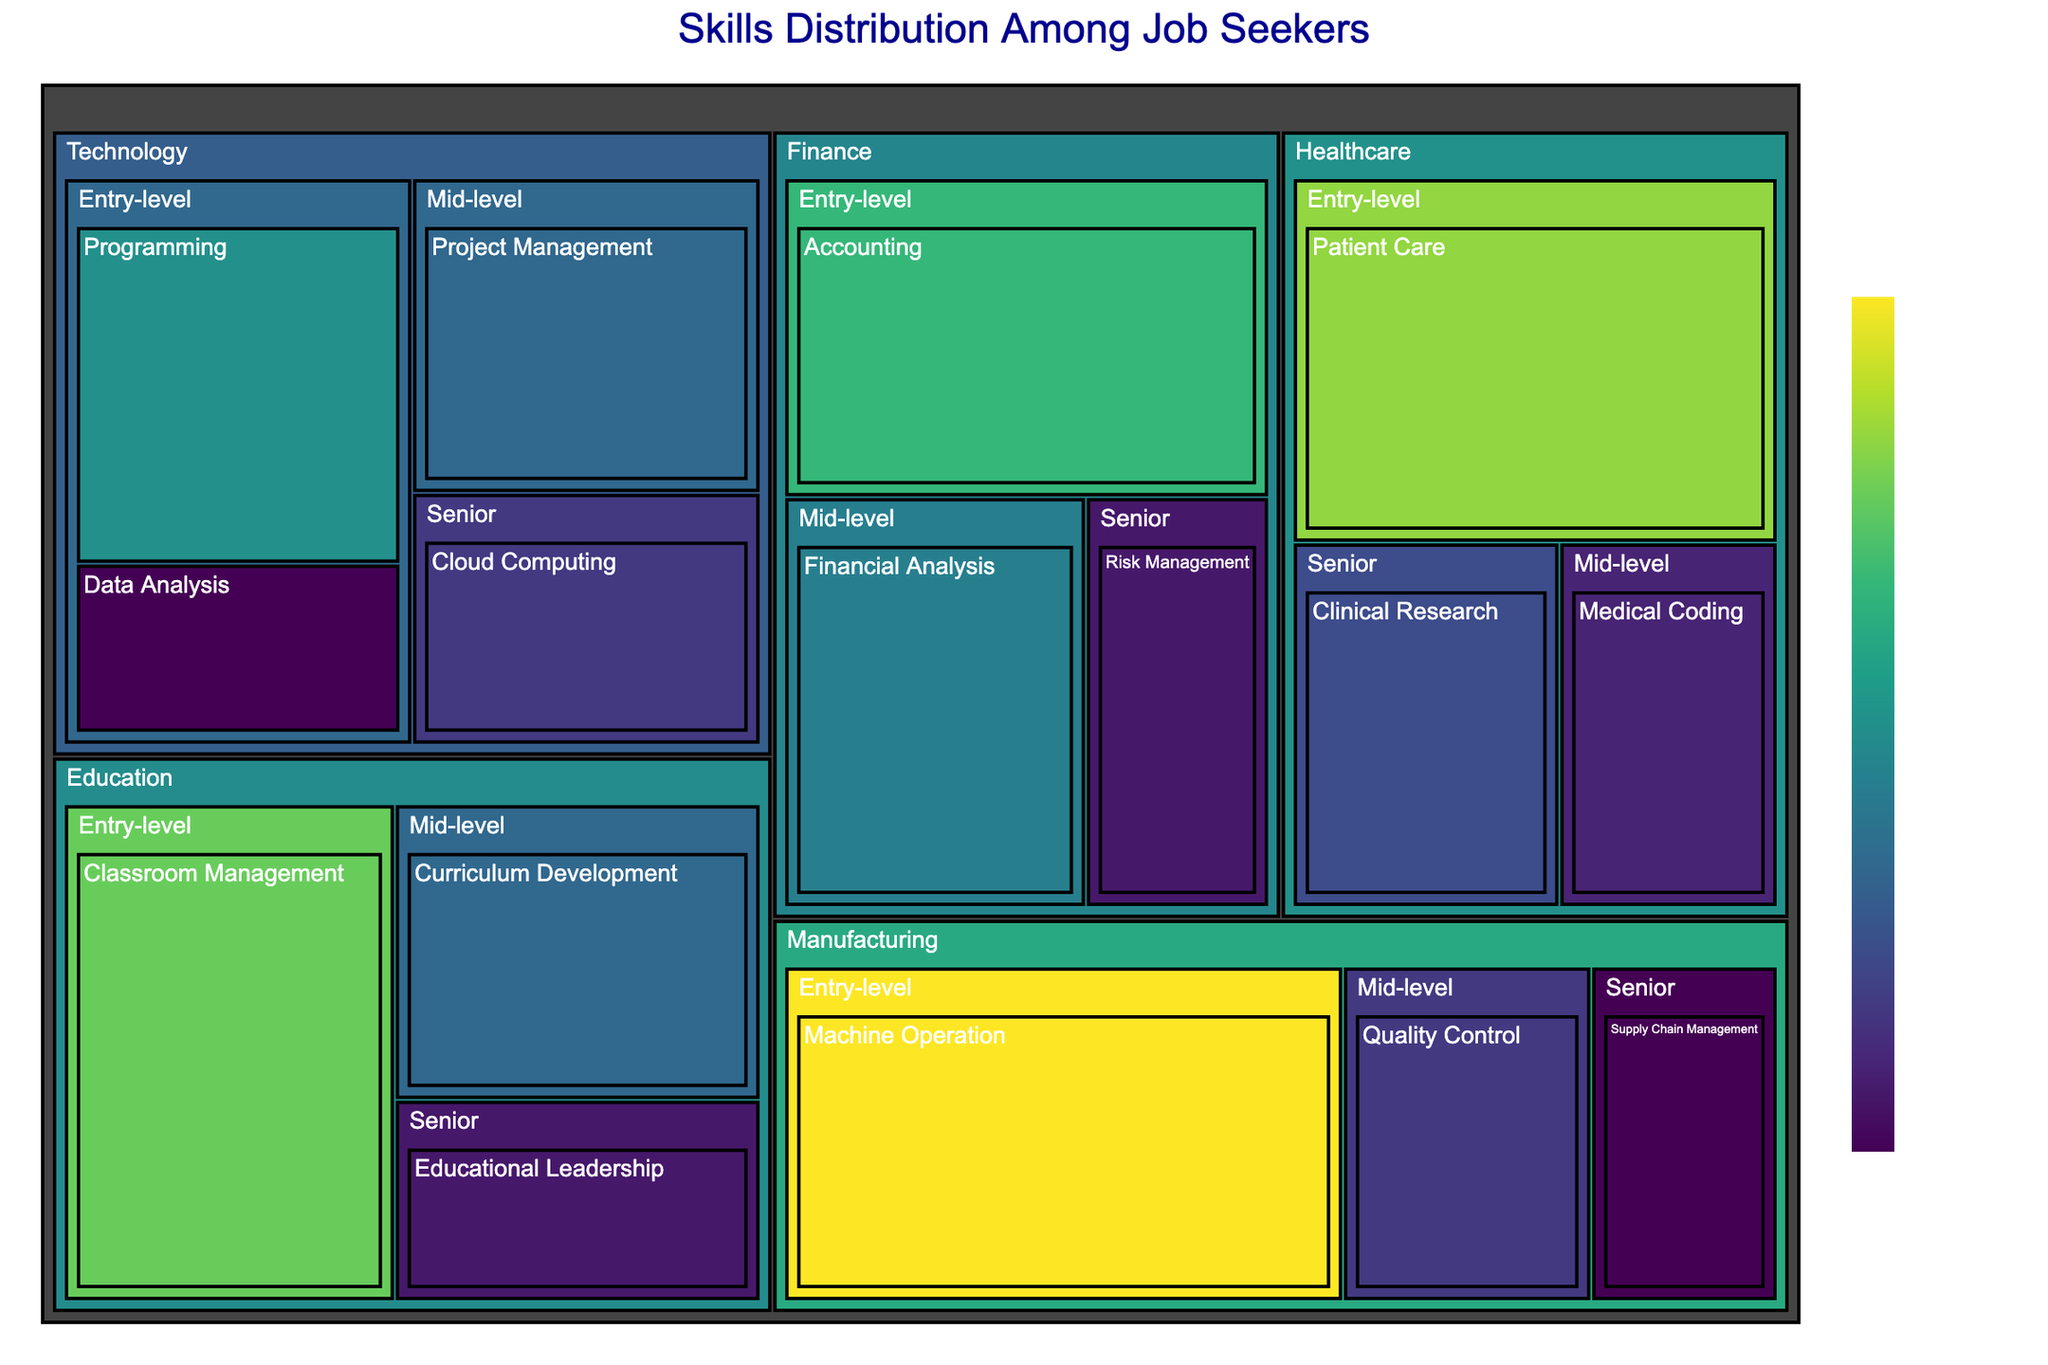What is the title of the treemap? The title of the treemap is usually displayed at the top and offers a summary of what the chart is about. Here, it is shown clearly in a large font.
Answer: Skills Distribution Among Job Seekers Which industry has the highest value for an entry-level skill, and what is that skill? Identify the entry-level category for each industry and look at the value of the skills listed. The highest value is where the rectangle size is the largest.
Answer: Manufacturing with Machine Operation Compare the skill demand in the Technology industry for entry-level and mid-level job seekers. Which level has a higher total demand? Sum the values of the skills for entry-level (30 + 15) and mid-level (25) job seekers in Technology. Entry-level: 45, Mid-level: 25. Entry-level has a higher total demand.
Answer: Entry-level What skill in Healthcare has the highest demand, and what is its value? Look at all the skills listed under Healthcare and identify the one with the largest value. This skill occupies the largest area in the treemap under Healthcare.
Answer: Patient Care with a value of 40 How does the value of risk management in Finance (senior) compare to educational leadership in Education (senior)? Find the values for both skills: Risk Management is 17, and Educational Leadership is 17. Since both values are equal, they have the same demand.
Answer: Equal Which industry has the least demand for senior-level skills, and what is the value of that skill? Check the senior-level category for each industry and identify the one with the smallest value.
Answer: Manufacturing with Supply Chain Management at 15 What is the combined value of skills in Finance at mid-level and senior-level? Find the values for mid-level and senior-level skills in Finance (28 + 17), then sum them up. 28 + 17 = 45.
Answer: 45 Compare the demand for Curriculum Development in Education (mid-level) and Project Management in Technology (mid-level). Which one is higher? Look at the values for Curriculum Development (25) and Project Management (25). Both have the same value.
Answer: Equal Which skill has the highest demand across all industries and experience levels, and what is its value? Identify the skill with the largest value, checking all industries and experience levels. This is the largest rectangle overall.
Answer: Machine Operation with 45 What is the average demand for entry-level skills across all industries? Add up the values of all entry-level skills and divide by the number of entry-level skills. Calculation: (30 + 15 + 40 + 35 + 45 + 38) / 6 = 203 / 6 ≈ 33.83
Answer: Approximately 33.83 